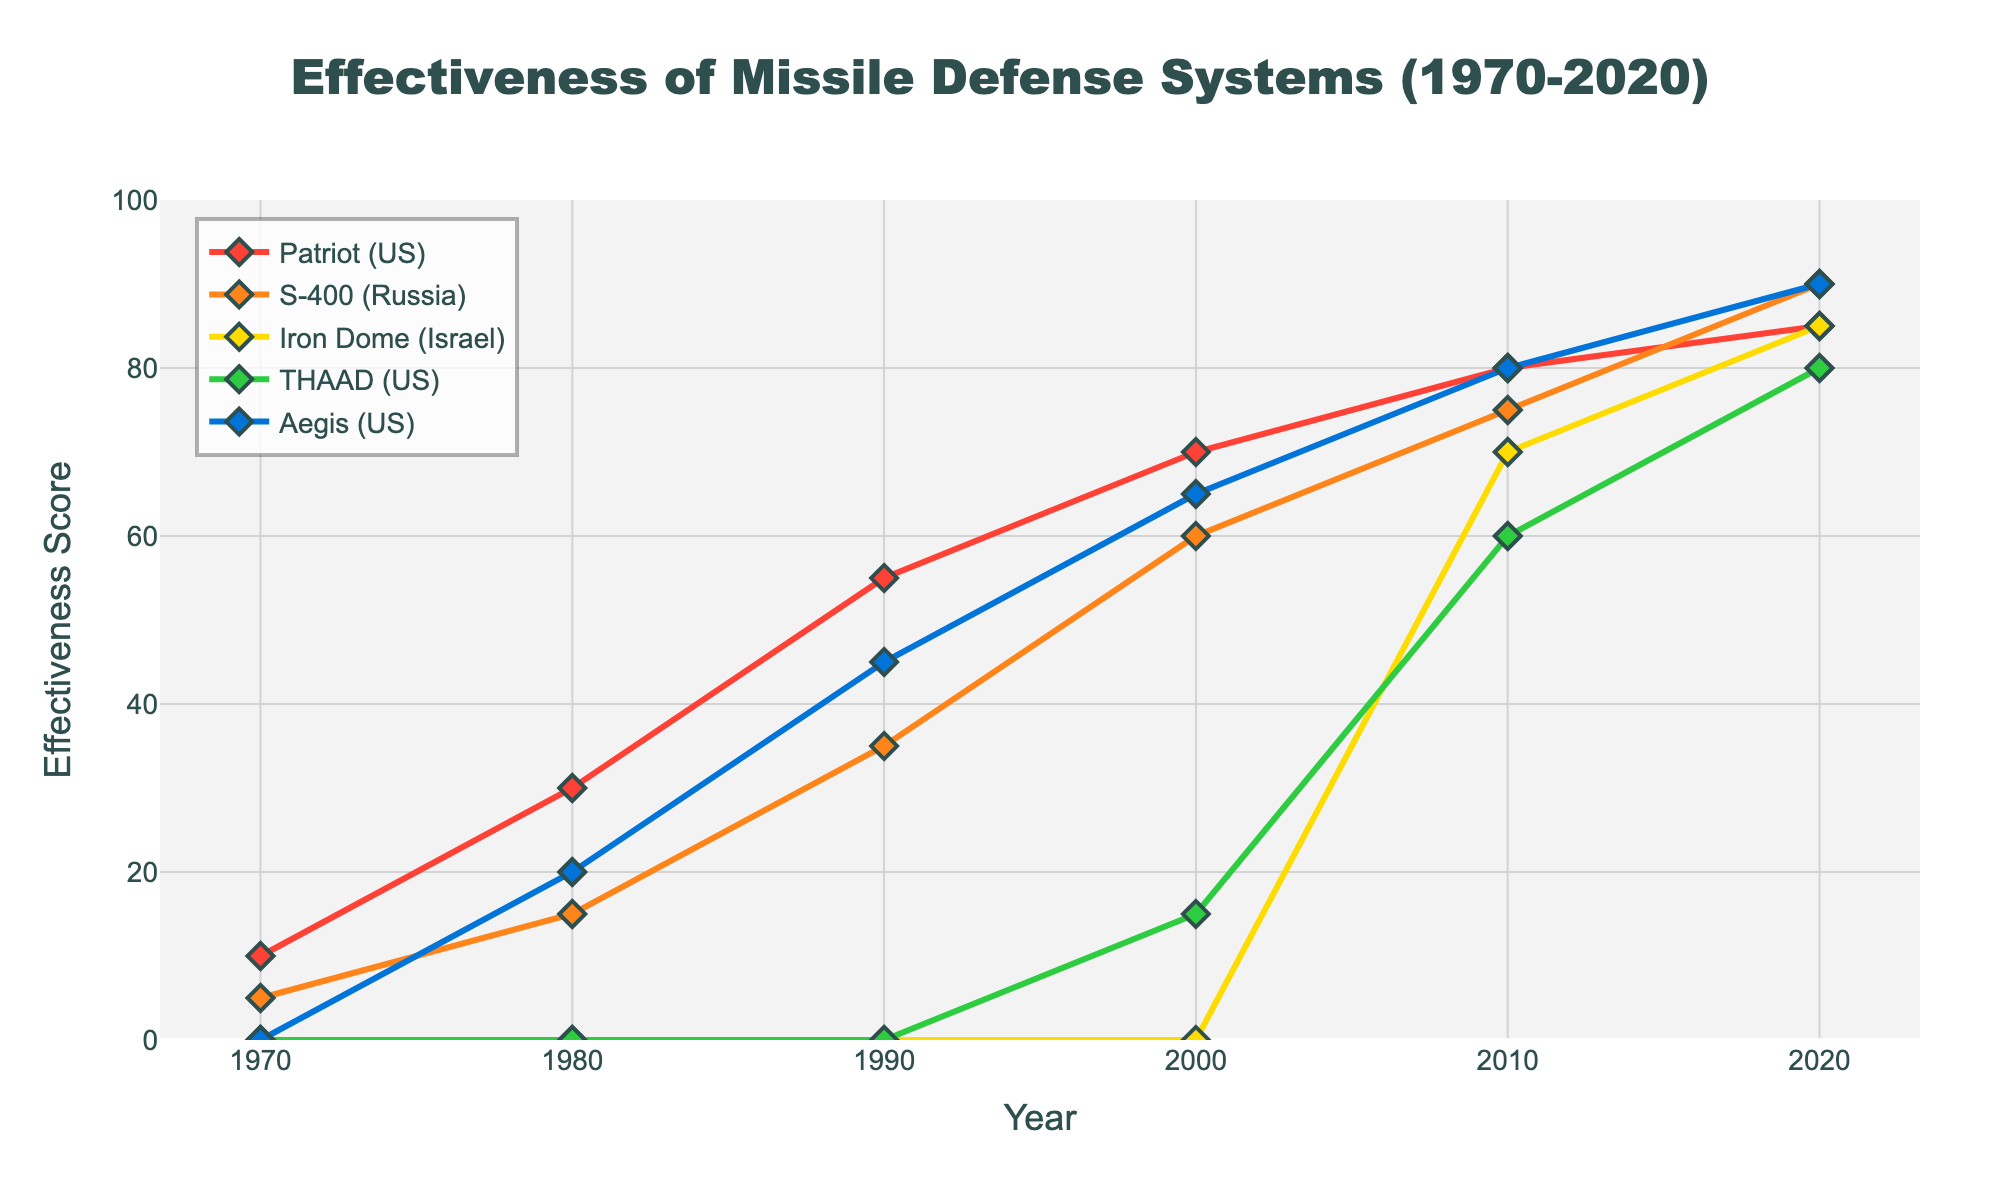What is the effectiveness score of the Patriot system in the year 2000? Locate the Patriot system series (red line with diamond markers) and find the value at the year 2000 on the x-axis. The y-value for this point represents the effectiveness score.
Answer: 70 Which missile defense system had the highest effectiveness score in 2010? Compare the y-values at the year 2010 for all systems (Patriot, S-400, Iron Dome, THAAD, Aegis) and identify the system with the highest value.
Answer: Patriot How has the effectiveness of the Aegis system changed from 1980 to 2020? Locate the Aegis system series (blue line with diamond markers) and observe the values at 1980 and 2020 on the x-axis. Calculate the change by subtracting the 1980 value from the 2020 value.
Answer: Increased by 70 Which system has shown the most consistent increase in effectiveness over the entire period? Examine the trends for each missile defense system. Look for the system with a steady upward trend without sharp declines.
Answer: S-400 What is the combined effectiveness of the Patriot and Iron Dome systems in 2020? Find the effectiveness scores for both Patriot and Iron Dome systems in 2020 and sum them up.
Answer: 170 Compare the effectiveness of the THAAD and Aegis systems in 2000. Which one was more effective and by how much? Locate the values for THAAD and Aegis systems in 2000. Subtract the THAAD value from the Aegis value to determine the difference.
Answer: Aegis by 50 Which three missile defense systems had the highest effectiveness scores in 2020? Identify the effectiveness scores for all systems in 2020 and rank them. Select the top three systems.
Answer: Patriot, S-400, Aegis What is the average effectiveness score of the Patriot system from 1970 to 2020? Sum the effectiveness scores of the Patriot system from each decade and divide by the number of data points (6).
Answer: 55 Has the Iron Dome system always had a non-zero effectiveness score in the given data? Check the Iron Dome series (yellow line with diamond markers) across all years for any points with a value of zero.
Answer: No What is the difference in effectiveness between the S-400 and Iron Dome systems in 2010? Find the effectiveness scores for S-400 and Iron Dome systems in 2010 and subtract the lower from the higher to calculate the difference.
Answer: 5 